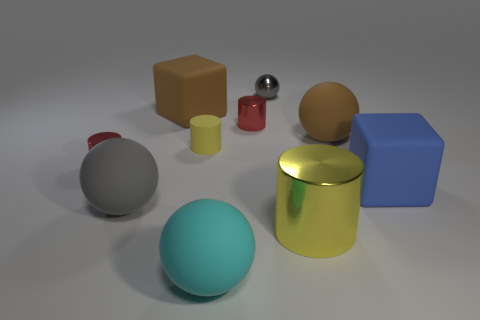Can you describe the shapes and colors of the objects? Certainly! The image displays a variety of geometric shapes: a blue cube, a beige cylinder, a gray sphere, a teal sphere, a red small cylinder, a yellow matte cylinder, and a small shiny sphere. The colors range from neutral grays and beige to more vibrant blues, red, yellow, and teal, making for a visually stimulating assortment. 